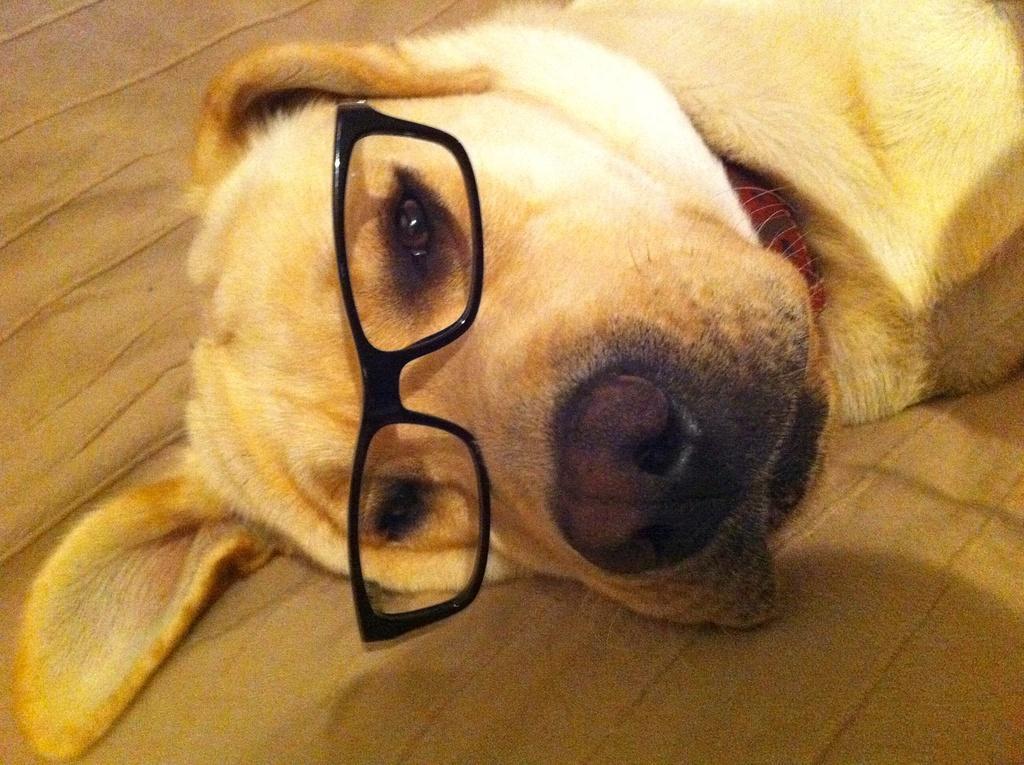In one or two sentences, can you explain what this image depicts? In this image in the center there is a dog laying on the floor and wearing spectacles. 